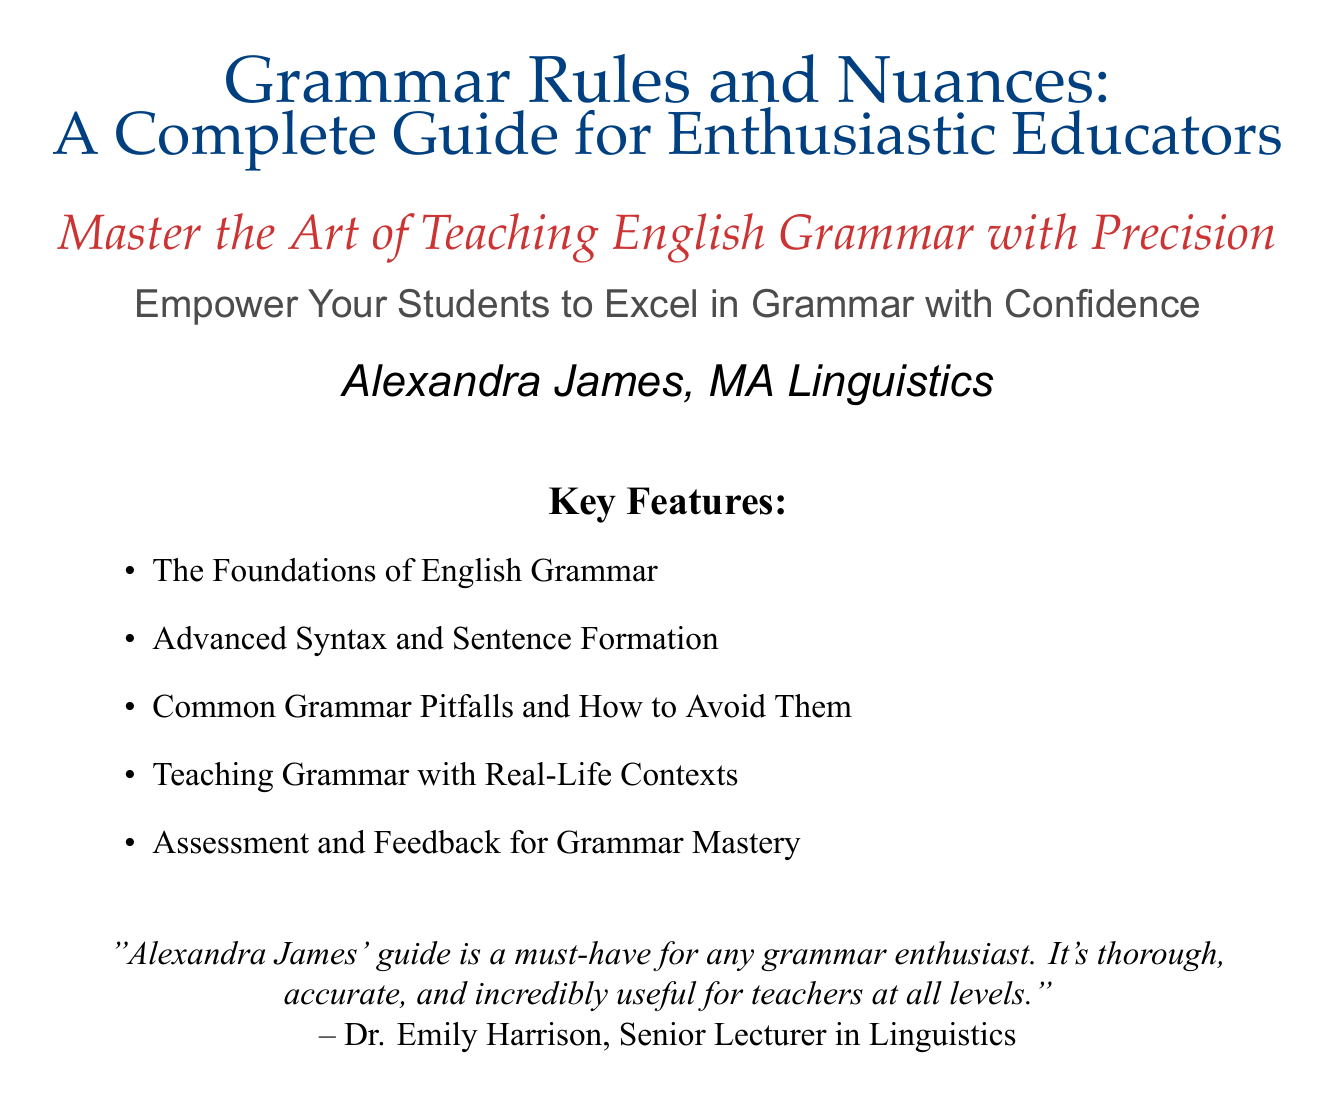What is the title of the book? The title is prominently displayed at the top of the cover.
Answer: Grammar Rules and Nuances Who is the author of the book? The author's name is listed below the title.
Answer: Alexandra James, MA Linguistics What is the subtitle of the book? The subtitle provides additional context about the content of the book.
Answer: A Complete Guide for Enthusiastic Educators What is one of the key features mentioned? The key features are listed on the cover, showcasing the content covered in the book.
Answer: Common Grammar Pitfalls and How to Avoid Them What type of feedback is provided on the book cover? The feedback is in the form of a quote from a prominent figure in the field.
Answer: "Alexandra James' guide is a must-have for any grammar enthusiast..." What color is used for the title font? The color of the title font is one of the features that stands out on the cover.
Answer: primaryblue How many key features are listed on the cover? The author aims to provide a comprehensive guide, indicated by the number of features.
Answer: five What is the purpose of the book as indicated by the tagline? The tagline outlines the intention behind the book and its target audience.
Answer: Empower Your Students to Excel in Grammar with Confidence What is the font used for the subtitle? The font choices help differentiate various text elements on the cover.
Answer: Palatino Italic 